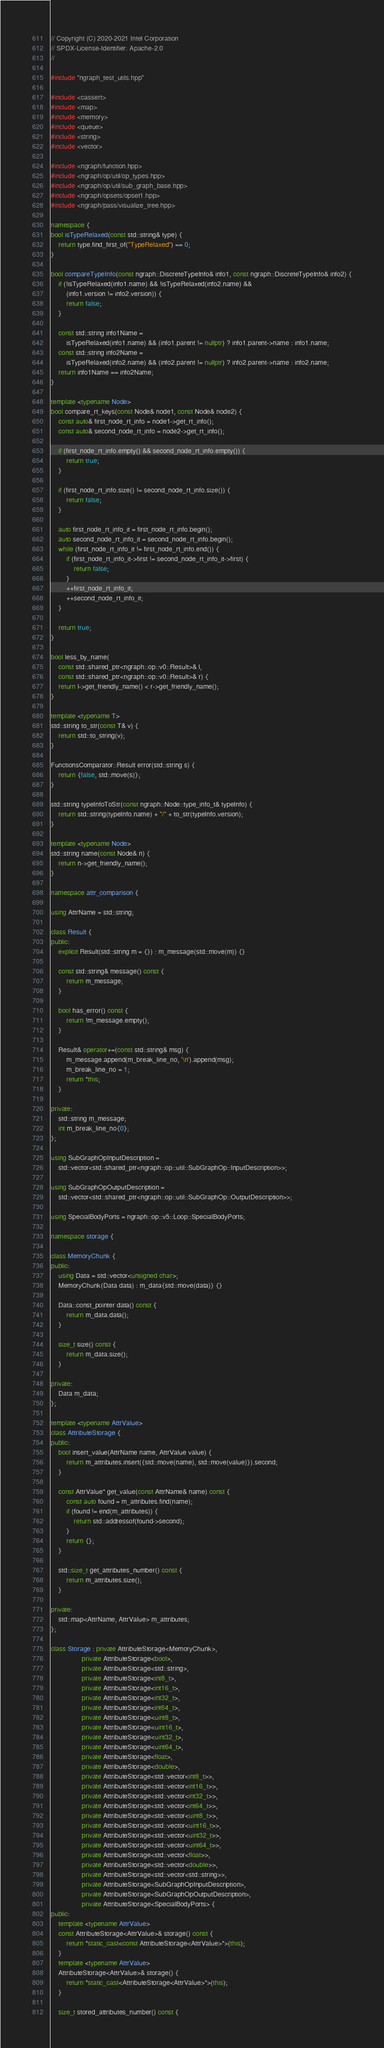<code> <loc_0><loc_0><loc_500><loc_500><_C++_>// Copyright (C) 2020-2021 Intel Corporation
// SPDX-License-Identifier: Apache-2.0
//

#include "ngraph_test_utils.hpp"

#include <cassert>
#include <map>
#include <memory>
#include <queue>
#include <string>
#include <vector>

#include <ngraph/function.hpp>
#include <ngraph/op/util/op_types.hpp>
#include <ngraph/op/util/sub_graph_base.hpp>
#include <ngraph/opsets/opset1.hpp>
#include <ngraph/pass/visualize_tree.hpp>

namespace {
bool isTypeRelaxed(const std::string& type) {
    return type.find_first_of("TypeRelaxed") == 0;
}

bool compareTypeInfo(const ngraph::DiscreteTypeInfo& info1, const ngraph::DiscreteTypeInfo& info2) {
    if (!isTypeRelaxed(info1.name) && !isTypeRelaxed(info2.name) &&
        (info1.version != info2.version)) {
        return false;
    }

    const std::string info1Name =
        isTypeRelaxed(info1.name) && (info1.parent != nullptr) ? info1.parent->name : info1.name;
    const std::string info2Name =
        isTypeRelaxed(info2.name) && (info2.parent != nullptr) ? info2.parent->name : info2.name;
    return info1Name == info2Name;
}

template <typename Node>
bool compare_rt_keys(const Node& node1, const Node& node2) {
    const auto& first_node_rt_info = node1->get_rt_info();
    const auto& second_node_rt_info = node2->get_rt_info();

    if (first_node_rt_info.empty() && second_node_rt_info.empty()) {
        return true;
    }

    if (first_node_rt_info.size() != second_node_rt_info.size()) {
        return false;
    }

    auto first_node_rt_info_it = first_node_rt_info.begin();
    auto second_node_rt_info_it = second_node_rt_info.begin();
    while (first_node_rt_info_it != first_node_rt_info.end()) {
        if (first_node_rt_info_it->first != second_node_rt_info_it->first) {
            return false;
        }
        ++first_node_rt_info_it;
        ++second_node_rt_info_it;
    }

    return true;
}

bool less_by_name(
    const std::shared_ptr<ngraph::op::v0::Result>& l,
    const std::shared_ptr<ngraph::op::v0::Result>& r) {
    return l->get_friendly_name() < r->get_friendly_name();
}

template <typename T>
std::string to_str(const T& v) {
    return std::to_string(v);
}

FunctionsComparator::Result error(std::string s) {
    return {false, std::move(s)};
}

std::string typeInfoToStr(const ngraph::Node::type_info_t& typeInfo) {
    return std::string(typeInfo.name) + "/" + to_str(typeInfo.version);
}

template <typename Node>
std::string name(const Node& n) {
    return n->get_friendly_name();
}

namespace attr_comparison {

using AttrName = std::string;

class Result {
public:
    explicit Result(std::string m = {}) : m_message(std::move(m)) {}

    const std::string& message() const {
        return m_message;
    }

    bool has_error() const {
        return !m_message.empty();
    }

    Result& operator+=(const std::string& msg) {
        m_message.append(m_break_line_no, '\n').append(msg);
        m_break_line_no = 1;
        return *this;
    }

private:
    std::string m_message;
    int m_break_line_no{0};
};

using SubGraphOpInputDescription =
    std::vector<std::shared_ptr<ngraph::op::util::SubGraphOp::InputDescription>>;

using SubGraphOpOutputDescription =
    std::vector<std::shared_ptr<ngraph::op::util::SubGraphOp::OutputDescription>>;

using SpecialBodyPorts = ngraph::op::v5::Loop::SpecialBodyPorts;

namespace storage {

class MemoryChunk {
public:
    using Data = std::vector<unsigned char>;
    MemoryChunk(Data data) : m_data{std::move(data)} {}

    Data::const_pointer data() const {
        return m_data.data();
    }

    size_t size() const {
        return m_data.size();
    }

private:
    Data m_data;
};

template <typename AttrValue>
class AttributeStorage {
public:
    bool insert_value(AttrName name, AttrValue value) {
        return m_attributes.insert({std::move(name), std::move(value)}).second;
    }

    const AttrValue* get_value(const AttrName& name) const {
        const auto found = m_attributes.find(name);
        if (found != end(m_attributes)) {
            return std::addressof(found->second);
        }
        return {};
    }

    std::size_t get_attributes_number() const {
        return m_attributes.size();
    }

private:
    std::map<AttrName, AttrValue> m_attributes;
};

class Storage : private AttributeStorage<MemoryChunk>,
                private AttributeStorage<bool>,
                private AttributeStorage<std::string>,
                private AttributeStorage<int8_t>,
                private AttributeStorage<int16_t>,
                private AttributeStorage<int32_t>,
                private AttributeStorage<int64_t>,
                private AttributeStorage<uint8_t>,
                private AttributeStorage<uint16_t>,
                private AttributeStorage<uint32_t>,
                private AttributeStorage<uint64_t>,
                private AttributeStorage<float>,
                private AttributeStorage<double>,
                private AttributeStorage<std::vector<int8_t>>,
                private AttributeStorage<std::vector<int16_t>>,
                private AttributeStorage<std::vector<int32_t>>,
                private AttributeStorage<std::vector<int64_t>>,
                private AttributeStorage<std::vector<uint8_t>>,
                private AttributeStorage<std::vector<uint16_t>>,
                private AttributeStorage<std::vector<uint32_t>>,
                private AttributeStorage<std::vector<uint64_t>>,
                private AttributeStorage<std::vector<float>>,
                private AttributeStorage<std::vector<double>>,
                private AttributeStorage<std::vector<std::string>>,
                private AttributeStorage<SubGraphOpInputDescription>,
                private AttributeStorage<SubGraphOpOutputDescription>,
                private AttributeStorage<SpecialBodyPorts> {
public:
    template <typename AttrValue>
    const AttributeStorage<AttrValue>& storage() const {
        return *static_cast<const AttributeStorage<AttrValue>*>(this);
    }
    template <typename AttrValue>
    AttributeStorage<AttrValue>& storage() {
        return *static_cast<AttributeStorage<AttrValue>*>(this);
    }

    size_t stored_attributes_number() const {</code> 